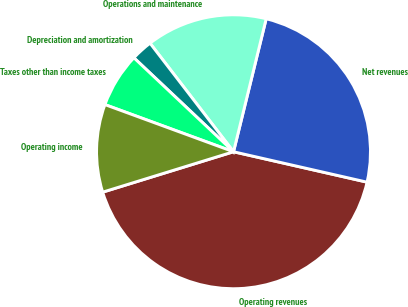Convert chart. <chart><loc_0><loc_0><loc_500><loc_500><pie_chart><fcel>Operating revenues<fcel>Net revenues<fcel>Operations and maintenance<fcel>Depreciation and amortization<fcel>Taxes other than income taxes<fcel>Operating income<nl><fcel>41.67%<fcel>24.73%<fcel>14.27%<fcel>2.53%<fcel>6.44%<fcel>10.36%<nl></chart> 